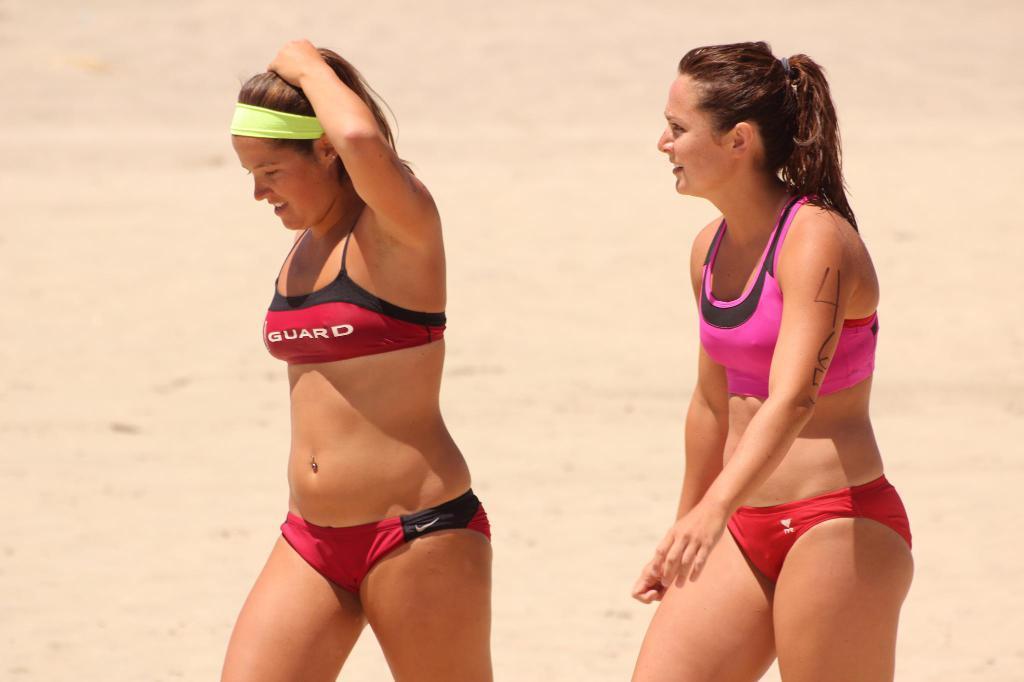Can you describe this image briefly? There are two women standing on the sand. 